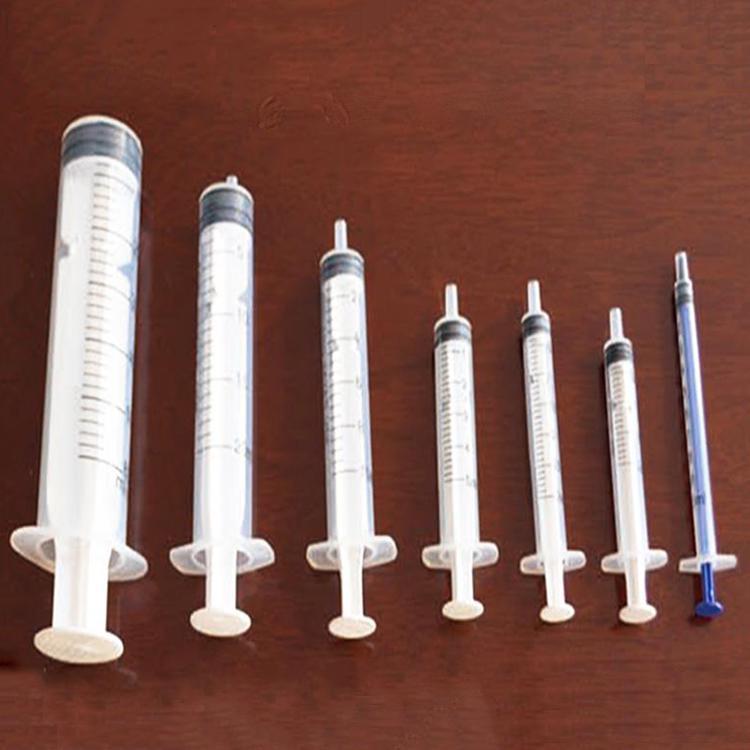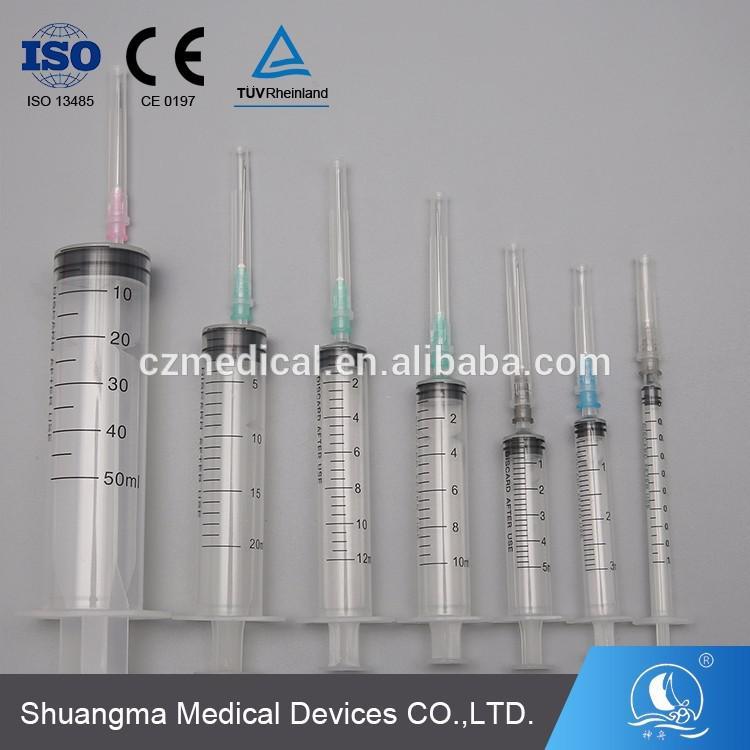The first image is the image on the left, the second image is the image on the right. Considering the images on both sides, is "At least one syringe needle is uncapped." valid? Answer yes or no. No. The first image is the image on the left, the second image is the image on the right. Assess this claim about the two images: "The left image shows a single syringe with needle attached.". Correct or not? Answer yes or no. No. 